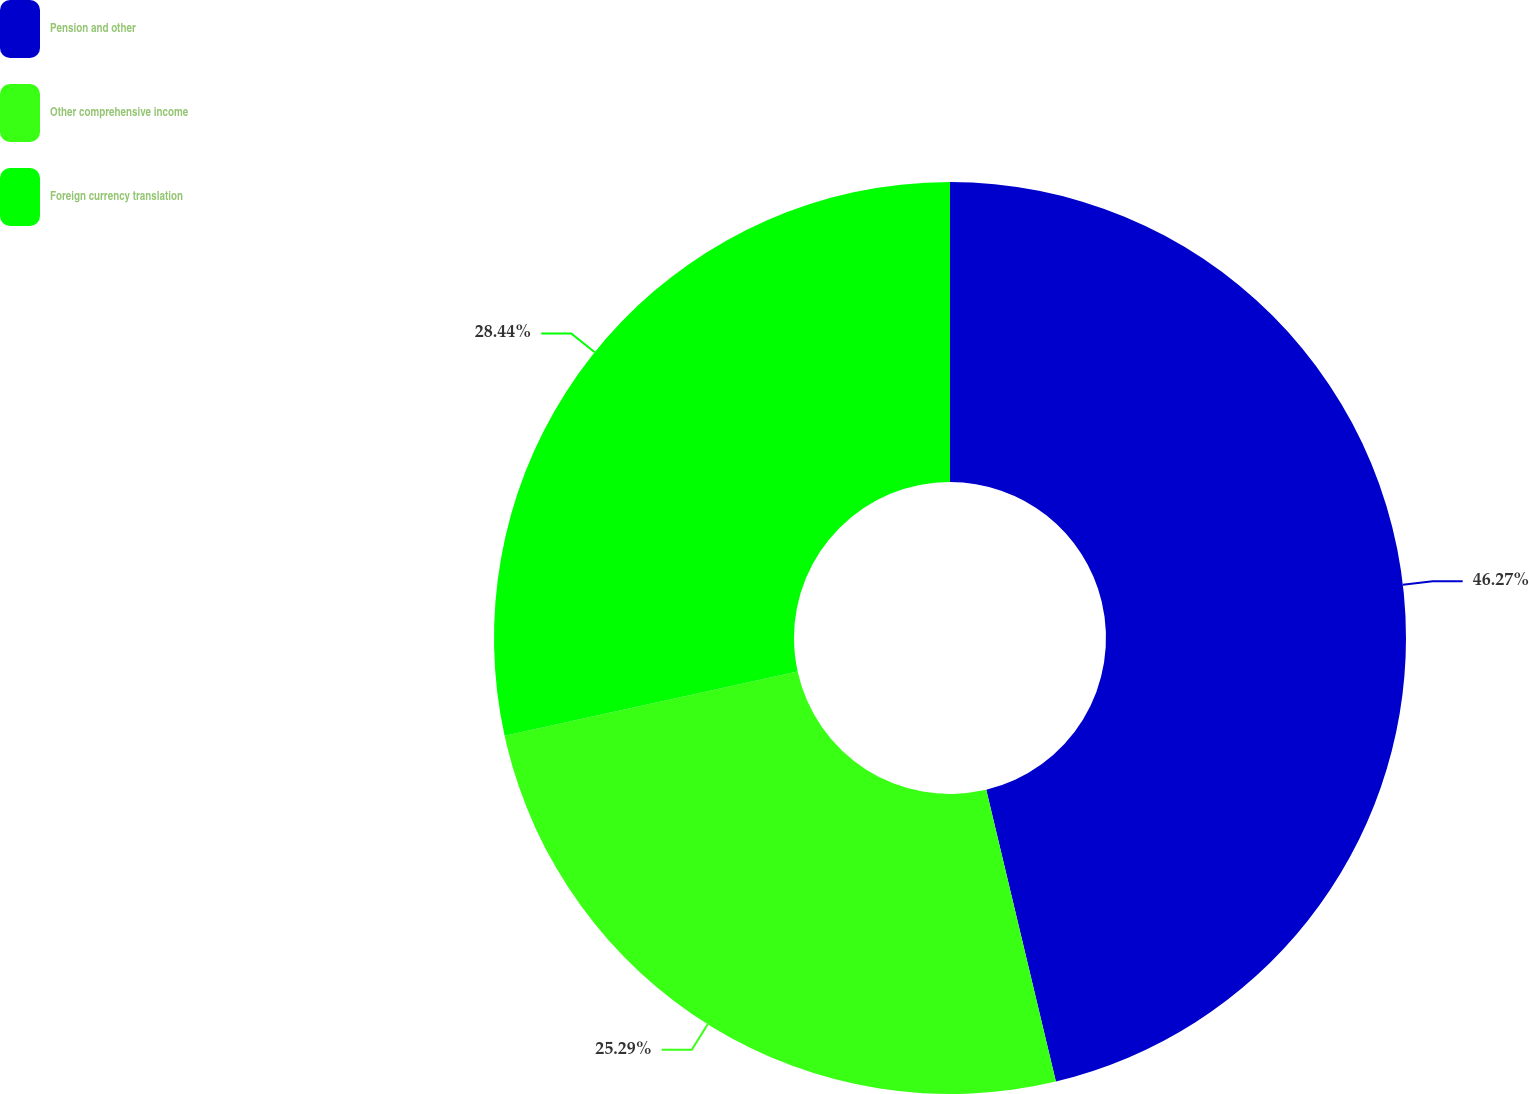<chart> <loc_0><loc_0><loc_500><loc_500><pie_chart><fcel>Pension and other<fcel>Other comprehensive income<fcel>Foreign currency translation<nl><fcel>46.27%<fcel>25.29%<fcel>28.44%<nl></chart> 